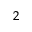Convert formula to latex. <formula><loc_0><loc_0><loc_500><loc_500>_ { 2 }</formula> 